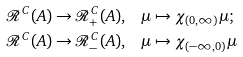Convert formula to latex. <formula><loc_0><loc_0><loc_500><loc_500>\mathcal { R } ^ { C } ( A ) \to \mathcal { R } ^ { C } _ { + } ( A ) , & \quad \mu \mapsto \chi _ { ( 0 , \infty ) } \mu ; \\ \mathcal { R } ^ { C } ( A ) \to \mathcal { R } ^ { C } _ { - } ( A ) , & \quad \mu \mapsto \chi _ { ( - \infty , 0 ) } \mu</formula> 